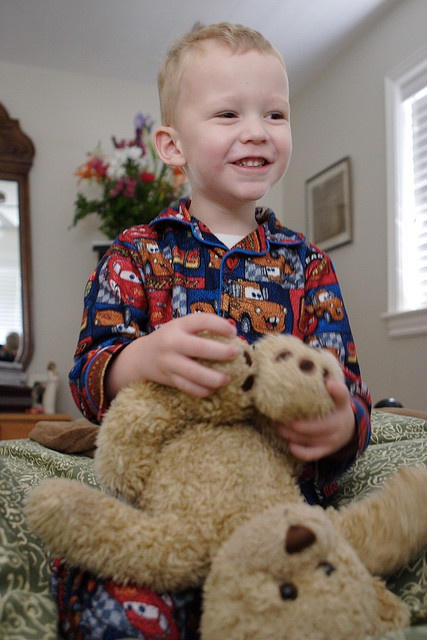Describe the objects in this image and their specific colors. I can see people in gray, black, and darkgray tones in this image. 